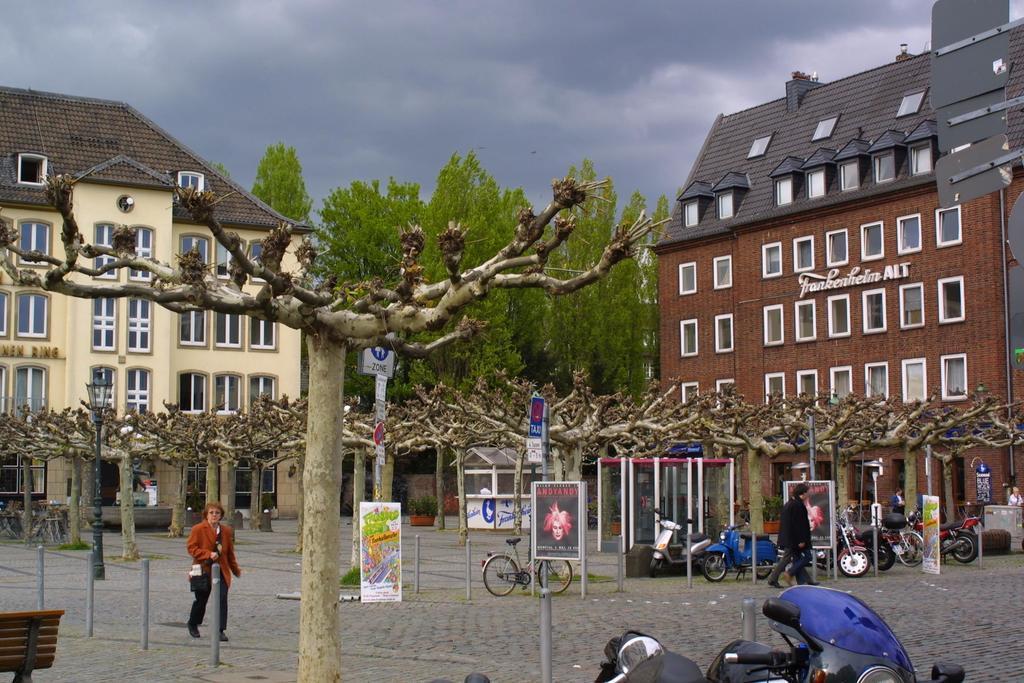Can you describe this image briefly? In this image we can see a few people, vehicles, bicycles, dried trees, plants in pots, in the bottom left corner we can see the chair, posters, metal poles, some written text on the board, we can see the buildings, glass windows, pipeline, we can see the trees, in the background we can see the sky with clouds. 